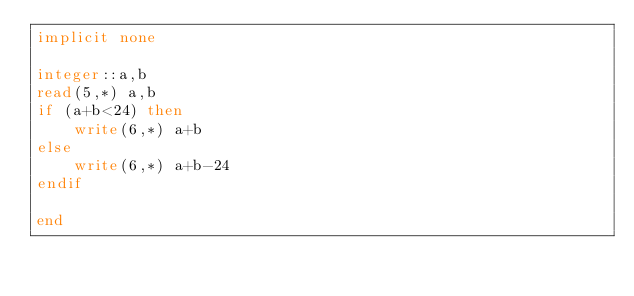Convert code to text. <code><loc_0><loc_0><loc_500><loc_500><_FORTRAN_>implicit none

integer::a,b
read(5,*) a,b
if (a+b<24) then
    write(6,*) a+b
else
    write(6,*) a+b-24
endif

end</code> 